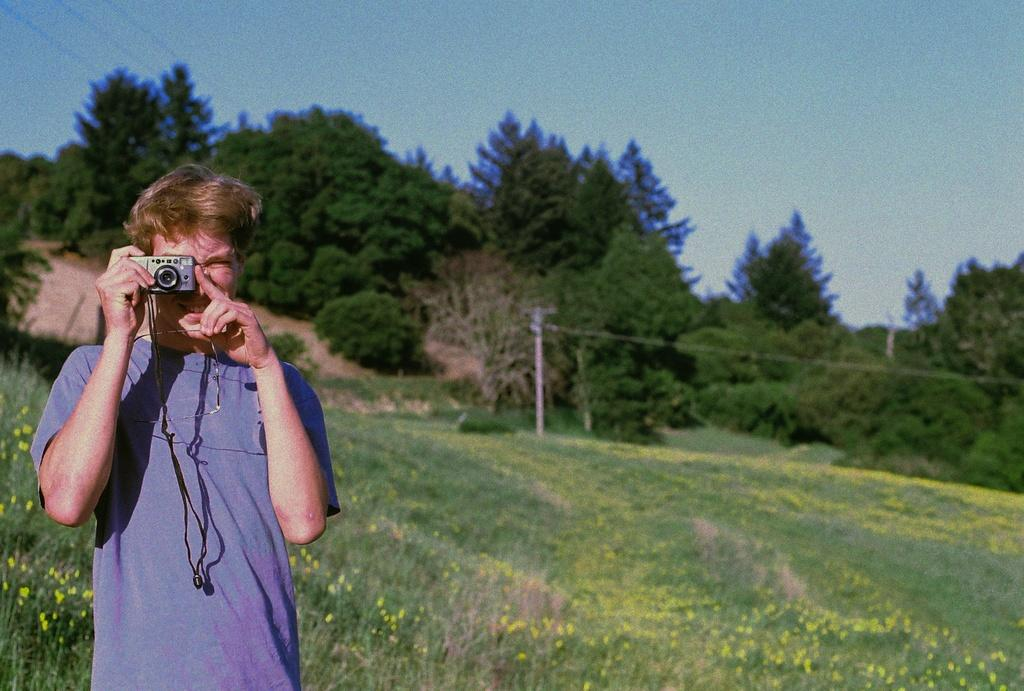What is the main subject of the image? There is a man in the image. What is the man doing in the image? The man is standing and holding a camera. What is the man wearing in the image? The man is wearing a t-shirt. What can be seen in the background of the image? There is grass, a pole, trees, and the sky visible in the background of the image. What type of iron can be seen in the image? There is no iron present in the image. Is there a house visible in the image? No, there is no house visible in the image. 